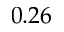Convert formula to latex. <formula><loc_0><loc_0><loc_500><loc_500>0 . 2 6</formula> 